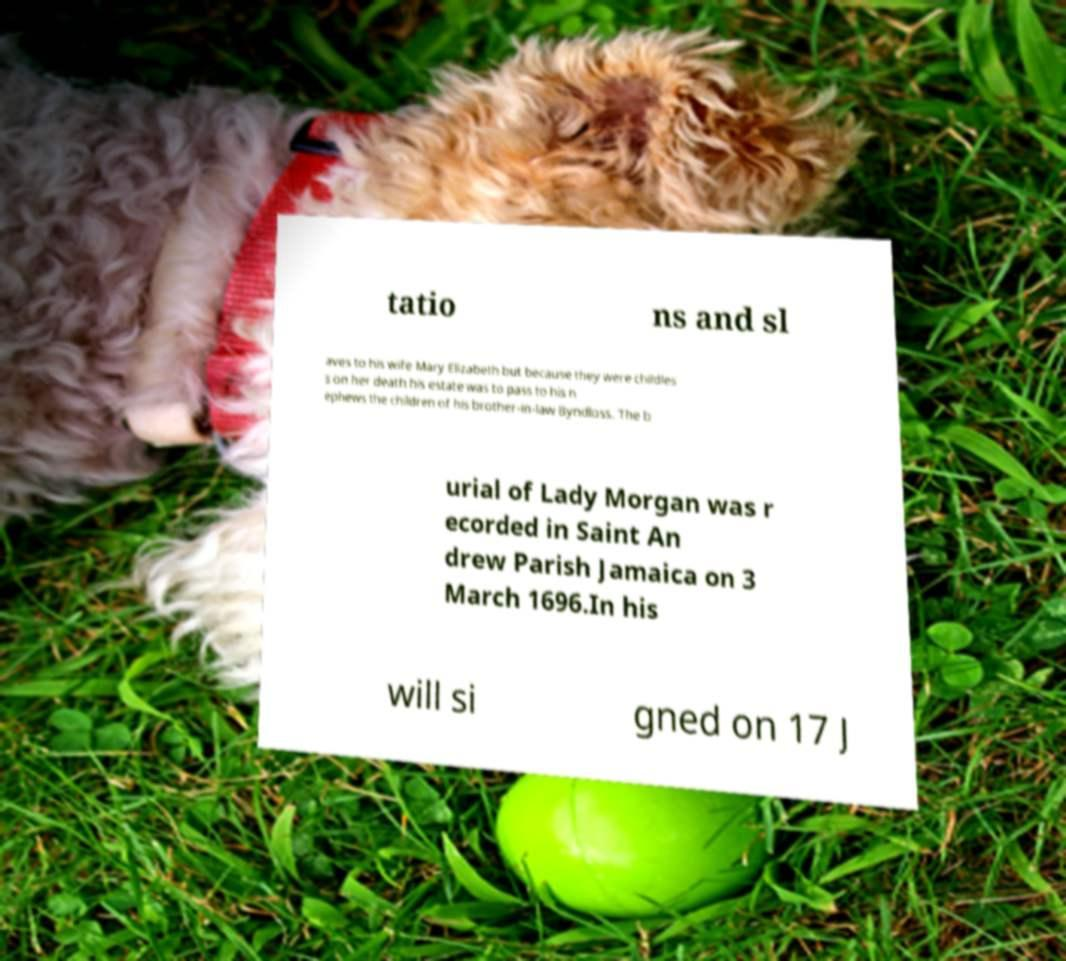What messages or text are displayed in this image? I need them in a readable, typed format. tatio ns and sl aves to his wife Mary Elizabeth but because they were childles s on her death his estate was to pass to his n ephews the children of his brother-in-law Byndloss. The b urial of Lady Morgan was r ecorded in Saint An drew Parish Jamaica on 3 March 1696.In his will si gned on 17 J 